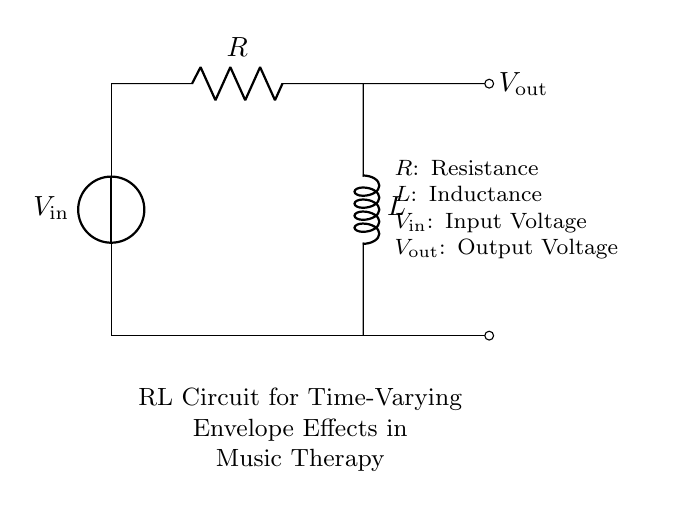What is the input voltage labeled in the circuit? The input voltage is labeled as V_in in the circuit diagram, indicating the voltage source connected to the circuit.
Answer: V_in What is the output voltage labeled in the circuit? The output voltage is labeled as V_out, which represents the voltage measured across the output node of the circuit.
Answer: V_out What are the components present in the RL circuit? The components present in the circuit are a resistor and an inductor, as indicated by the labels R and L, respectively.
Answer: Resistor and Inductor What connection type is used between the resistor and inductor? The connection type between the resistor and inductor is a series connection, as they are aligned in a single path directing current flow.
Answer: Series What effect does the inductor have on the time response of the circuit? The inductor introduces a time delay in the current response due to its property of opposing changes in current, which is relevant for crafting envelope effects in music therapy.
Answer: Time delay How does resistance affect the circuit's response time? Resistance affects the circuit's transient response time by determining the rate at which current builds up in the circuit, thereby influencing the envelope shaping for music therapy applications.
Answer: Determines response time What is the overall function of this RL circuit in music therapy? The overall function of this RL circuit is to create time-varying envelope effects, which can be used to modulate sound characteristics for therapeutic applications.
Answer: Time-varying envelope effects 